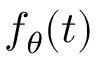<formula> <loc_0><loc_0><loc_500><loc_500>f _ { \theta } ( t )</formula> 